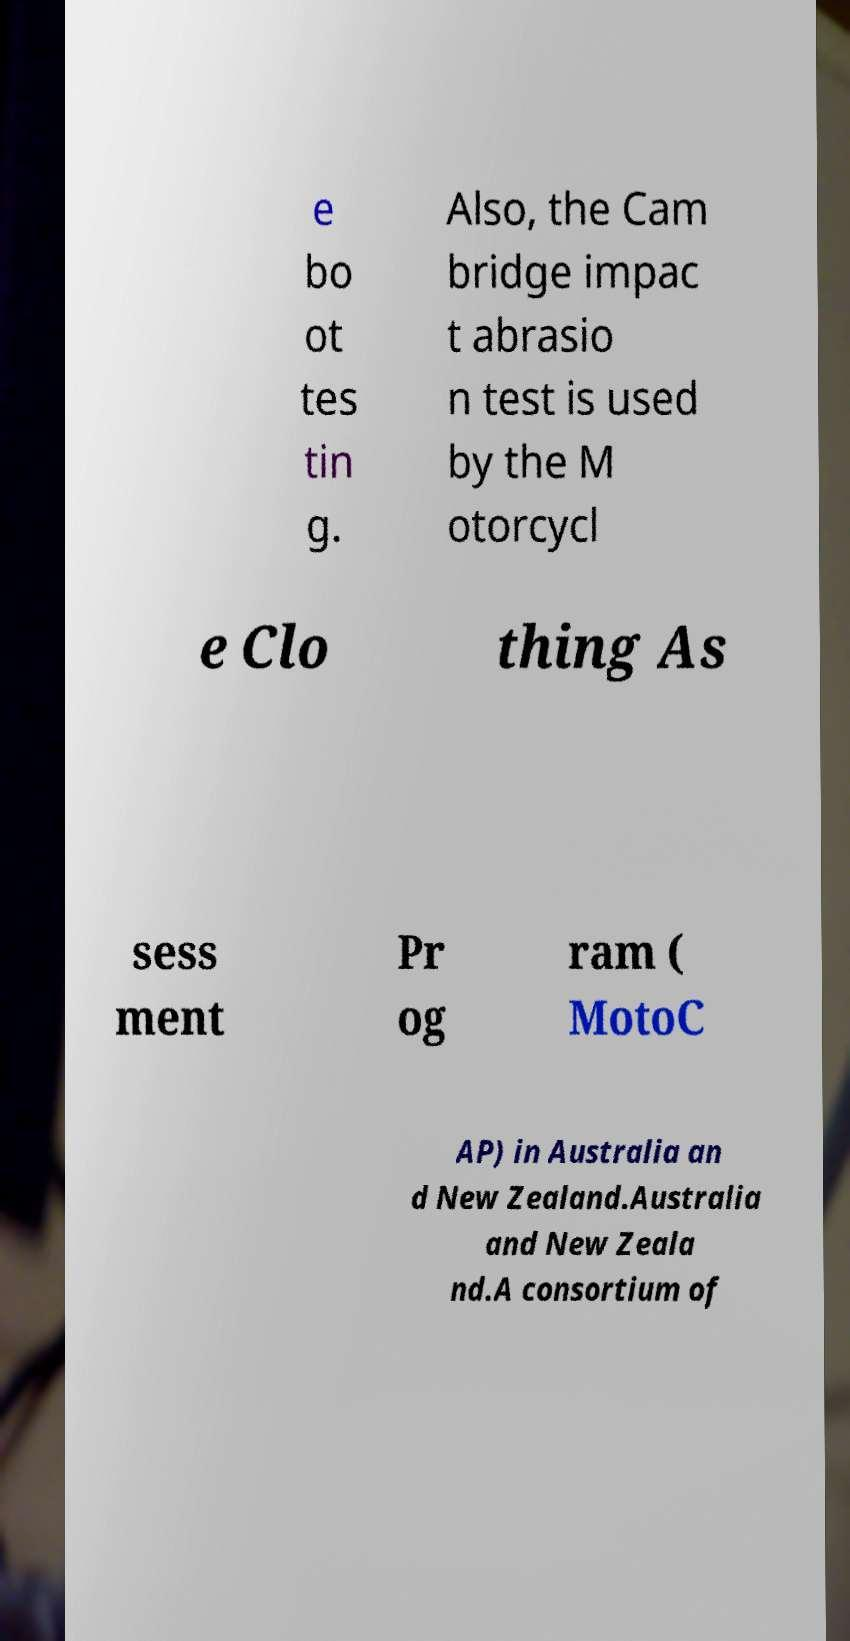For documentation purposes, I need the text within this image transcribed. Could you provide that? e bo ot tes tin g. Also, the Cam bridge impac t abrasio n test is used by the M otorcycl e Clo thing As sess ment Pr og ram ( MotoC AP) in Australia an d New Zealand.Australia and New Zeala nd.A consortium of 